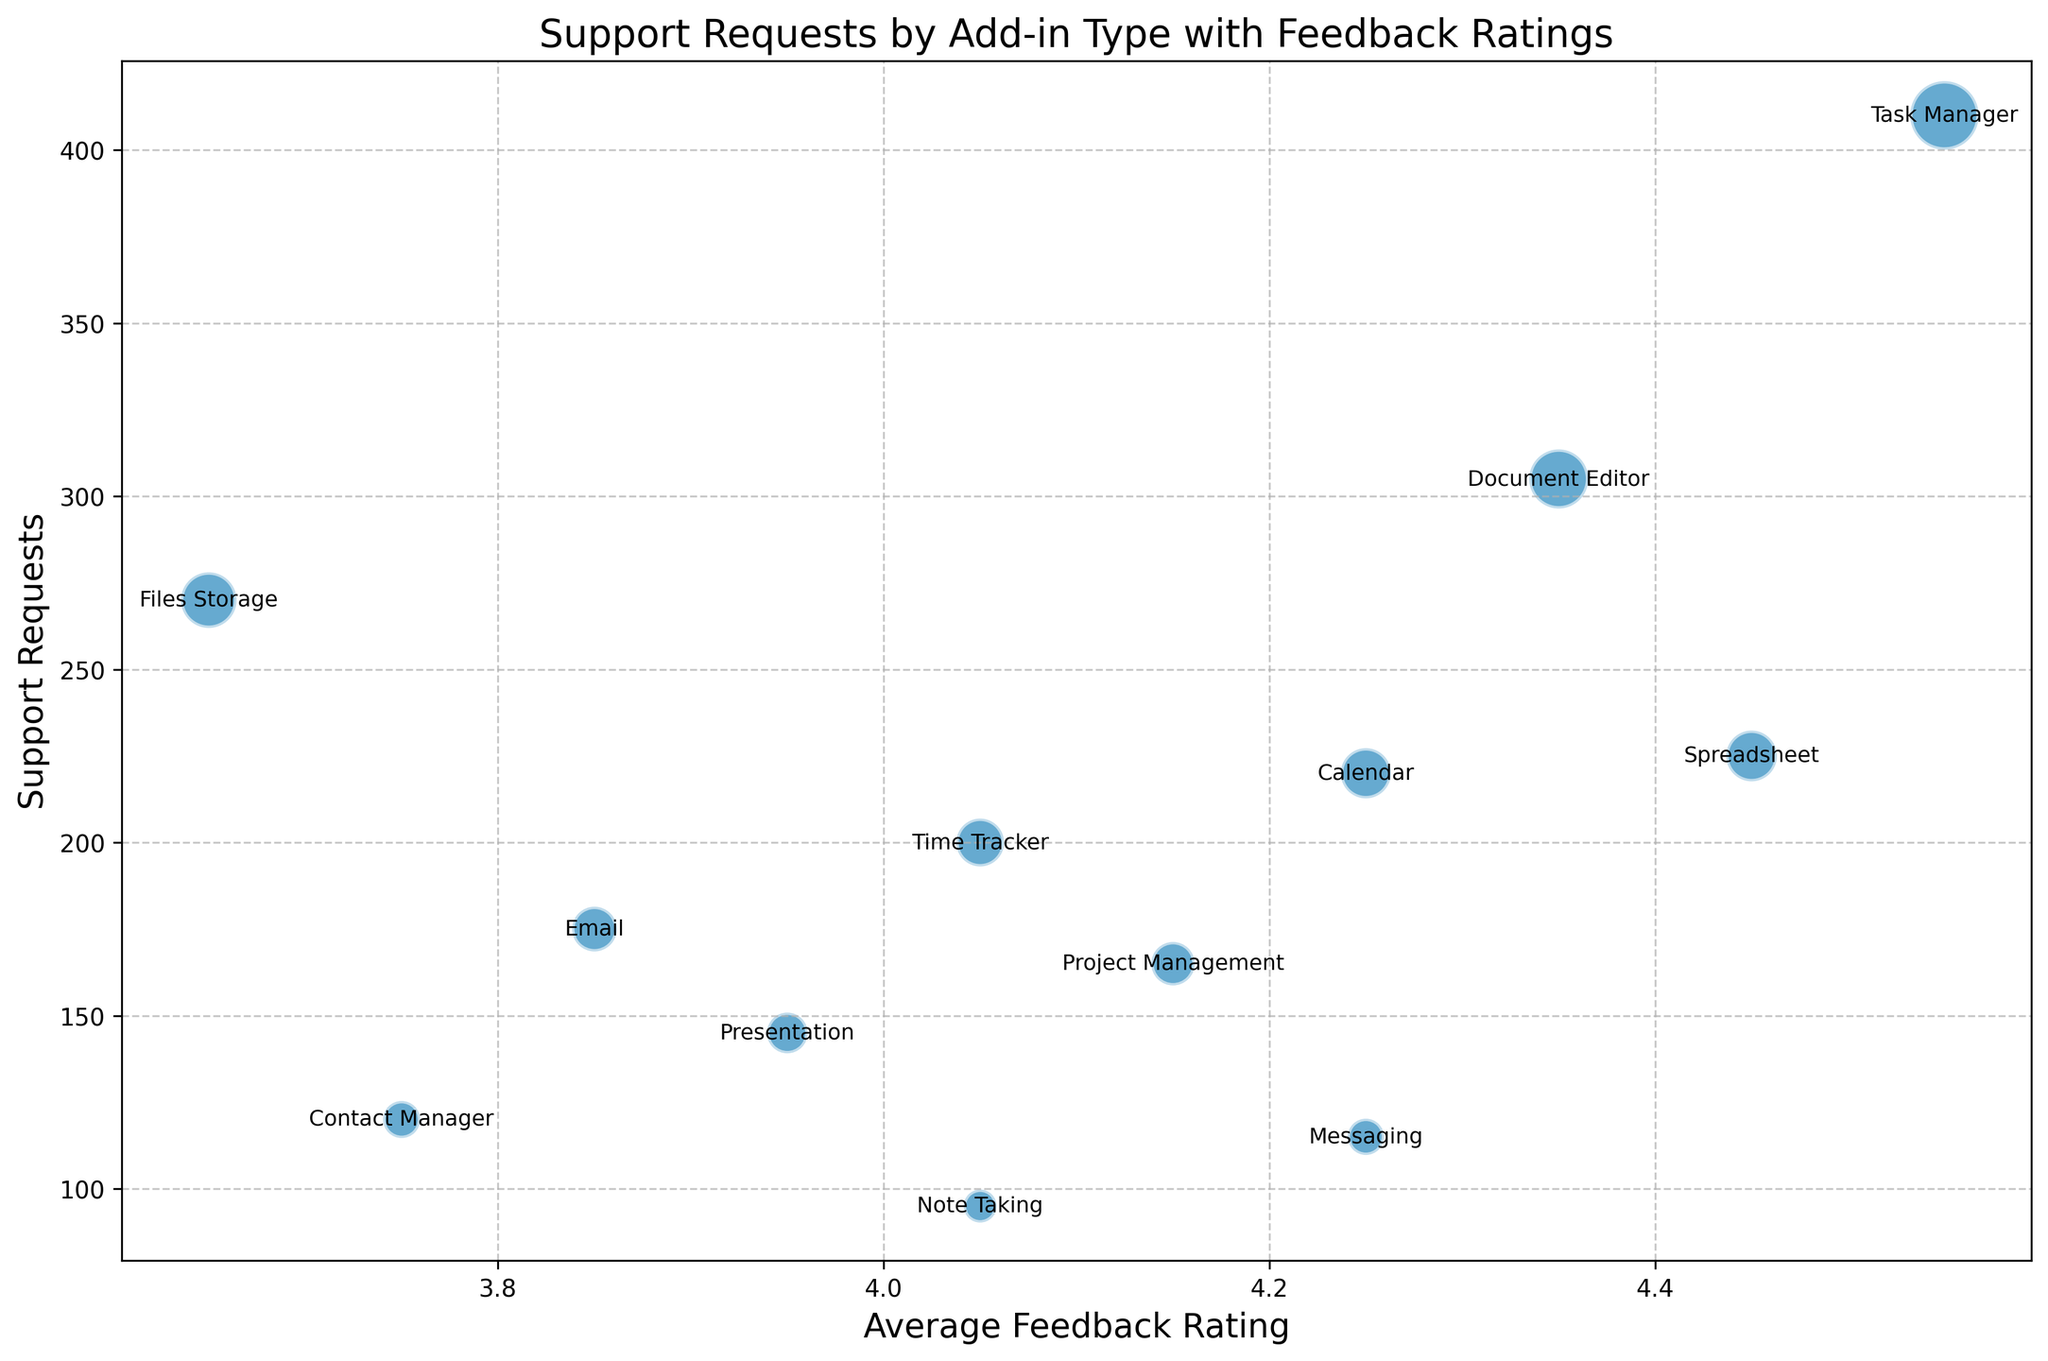What add-in type has the most support requests? By examining the y-axis which depicts the support requests, the "Task Manager" add-in reaches the highest value, meaning it has the most support requests.
Answer: Task Manager Which add-in types have an average feedback rating above 4.1? By looking at the x-axis, add-ins with an average feedback rating above 4.1 can be identified. "Calendar," "Task Manager," "Document Editor," "Spreadsheet," and "Messaging" all have ratings above 4.1.
Answer: Calendar, Task Manager, Document Editor, Spreadsheet, Messaging How do the support requests for "Document Editor" compare to those for "Email"? From the chart, the "Document Editor" has a higher y-axis value compared to "Email," indicating it has more support requests.
Answer: Document Editor has more support requests than Email What is the total number of support requests for add-in types with average feedback ratings below 4.0? Identify add-ins with ratings below 4.0 on the x-axis and sum their y-values. "Contact Manager," "Files Storage," and "Email" fall into this category. Sum their support requests: 120 + 270 + 175 = 565.
Answer: 565 Which add-in type has the highest average feedback rating, and what is its number of support requests? The highest x-value represents the highest feedback rating, which belongs to the "Task Manager" at around 4.55. By checking its y-axis value, it has approximately 410 support requests.
Answer: Task Manager, 410 What can be said about the relationship between support requests and average feedback rating for "Messaging"? The "Messaging" add-in has a relatively high average feedback rating of around 4.25 and a low number of support requests, around 115, suggesting well-rated but fewer support requests.
Answer: High rating, low support requests Which add-in type, "Calendar" or "Spreadsheet," has more support requests, and what is their difference? By comparing the y-axis values, "Spreadsheet" has fewer support requests than "Calendar." The difference is 245 (Calendar) - 225 (Spreadsheet) = 20.
Answer: Calendar has 20 more support requests than Spreadsheet For the add-ins with an average feedback rating of 4.0, what is the total number of support requests? Locate add-ins with a 4.0 rating: "Note Taking," "Presentation," and "Time Tracker." Sum their support requests: 95 + 145 + 200 = 440.
Answer: 440 Is there any add-in type that has both low support requests and a low average feedback rating? "Files Storage" has a low average feedback rating of around 3.65 and relatively low support requests at approximately 270.
Answer: Files Storage Which add-in type has the least support requests, and what is its average feedback rating? The "Note Taking" add-in has the least support requests, which is around 95. Its average feedback rating is around 4.05.
Answer: Note Taking, 4.05 